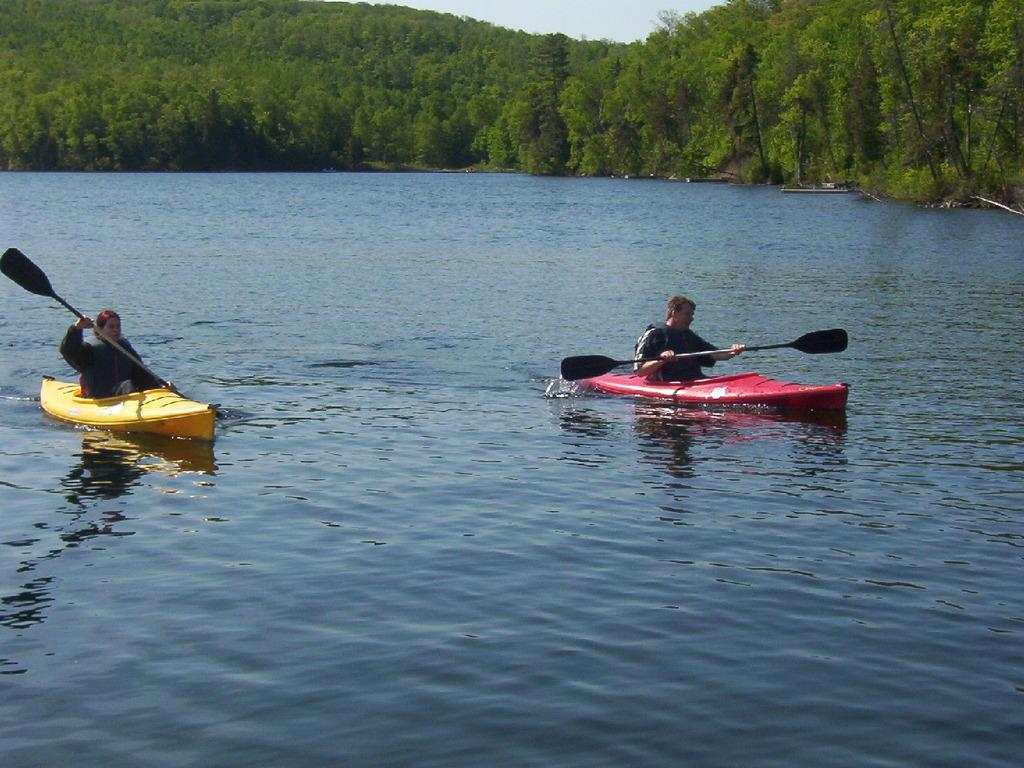What type of vehicles are in the water in the image? There are boats in the water in the image. How many people are on the boat? Two persons are sitting on a boat. What are the persons holding while on the boat? The persons are holding paddles. What can be seen in the background of the image? There are trees and the sky visible in the background. What type of yarn is being used by the persons on the boat? There is no yarn present in the image; the persons are holding paddles. How does the oil in the water affect the health of the persons on the boat? There is no oil present in the water in the image, so its effect on the health of the persons cannot be determined. 